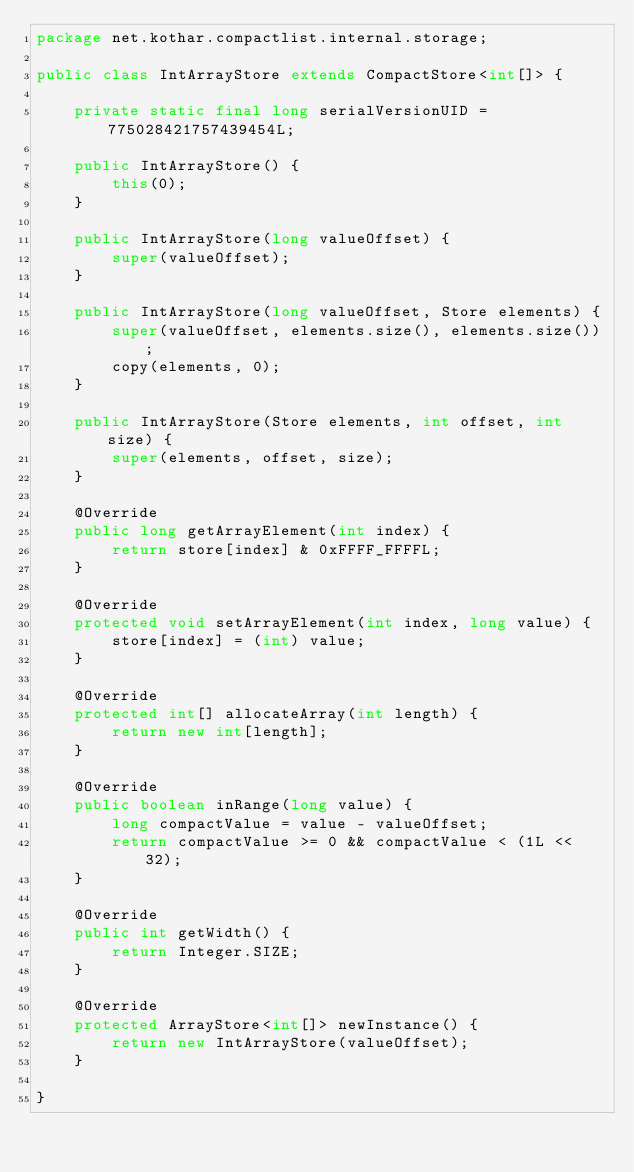Convert code to text. <code><loc_0><loc_0><loc_500><loc_500><_Java_>package net.kothar.compactlist.internal.storage;

public class IntArrayStore extends CompactStore<int[]> {

	private static final long serialVersionUID = 775028421757439454L;

	public IntArrayStore() {
		this(0);
	}

	public IntArrayStore(long valueOffset) {
		super(valueOffset);
	}

	public IntArrayStore(long valueOffset, Store elements) {
		super(valueOffset, elements.size(), elements.size());
		copy(elements, 0);
	}

	public IntArrayStore(Store elements, int offset, int size) {
		super(elements, offset, size);
	}

	@Override
	public long getArrayElement(int index) {
		return store[index] & 0xFFFF_FFFFL;
	}

	@Override
	protected void setArrayElement(int index, long value) {
		store[index] = (int) value;
	}

	@Override
	protected int[] allocateArray(int length) {
		return new int[length];
	}

	@Override
	public boolean inRange(long value) {
		long compactValue = value - valueOffset;
		return compactValue >= 0 && compactValue < (1L << 32);
	}

	@Override
	public int getWidth() {
		return Integer.SIZE;
	}

	@Override
	protected ArrayStore<int[]> newInstance() {
		return new IntArrayStore(valueOffset);
	}

}
</code> 